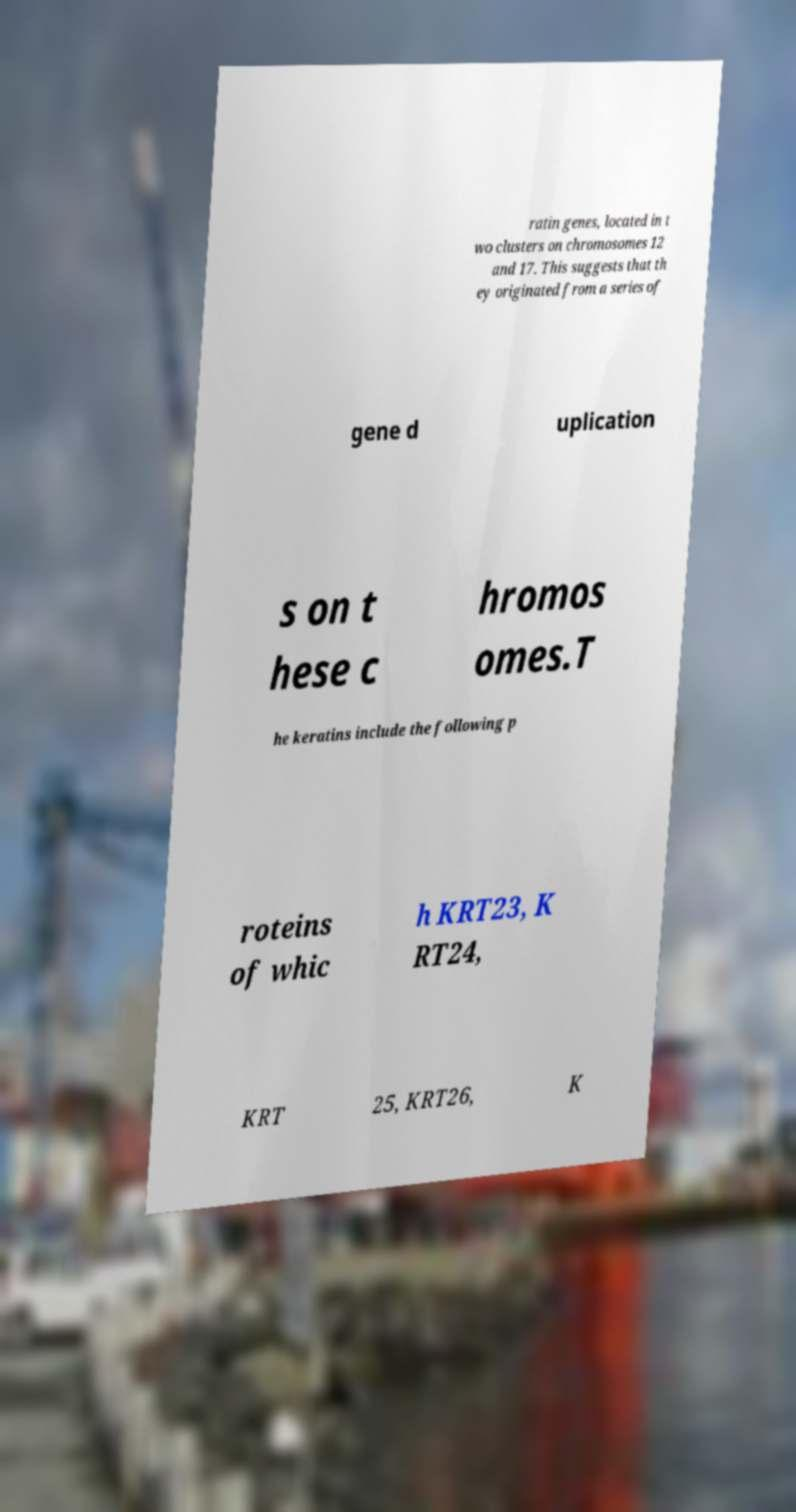Can you accurately transcribe the text from the provided image for me? ratin genes, located in t wo clusters on chromosomes 12 and 17. This suggests that th ey originated from a series of gene d uplication s on t hese c hromos omes.T he keratins include the following p roteins of whic h KRT23, K RT24, KRT 25, KRT26, K 